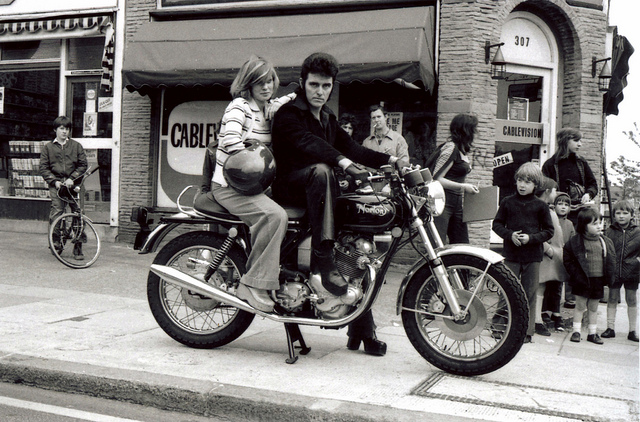Read and extract the text from this image. 307 CABLEVISION OPEN 